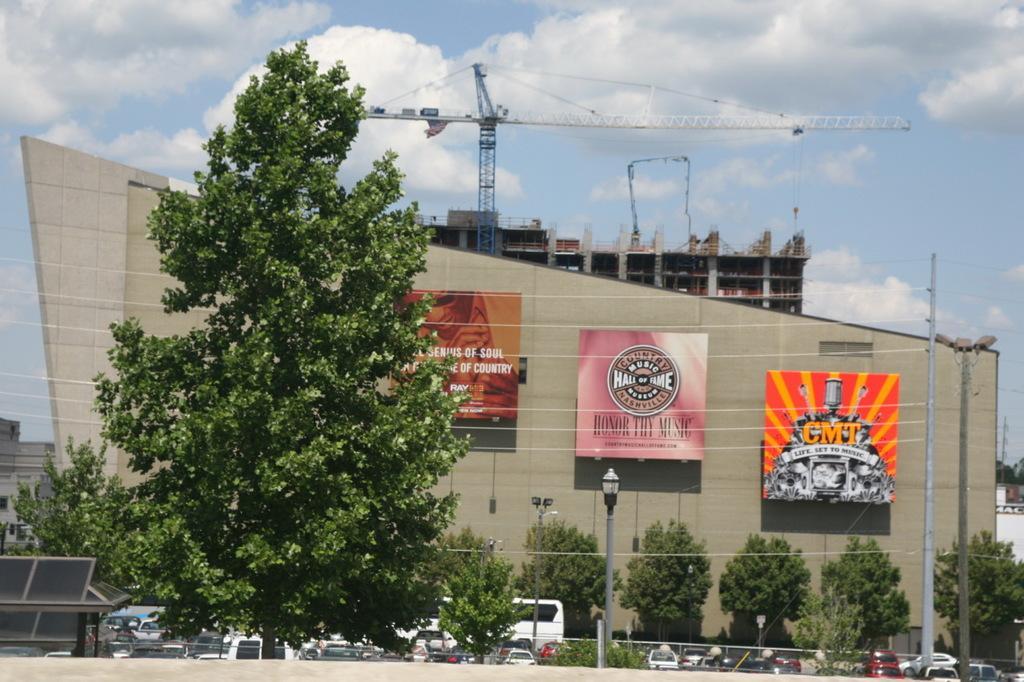Could you give a brief overview of what you see in this image? In this image in the middle, there are trees, posters, buildings, tower, poles, street lights, cars, vehicles. At the top there is sky and clouds. 